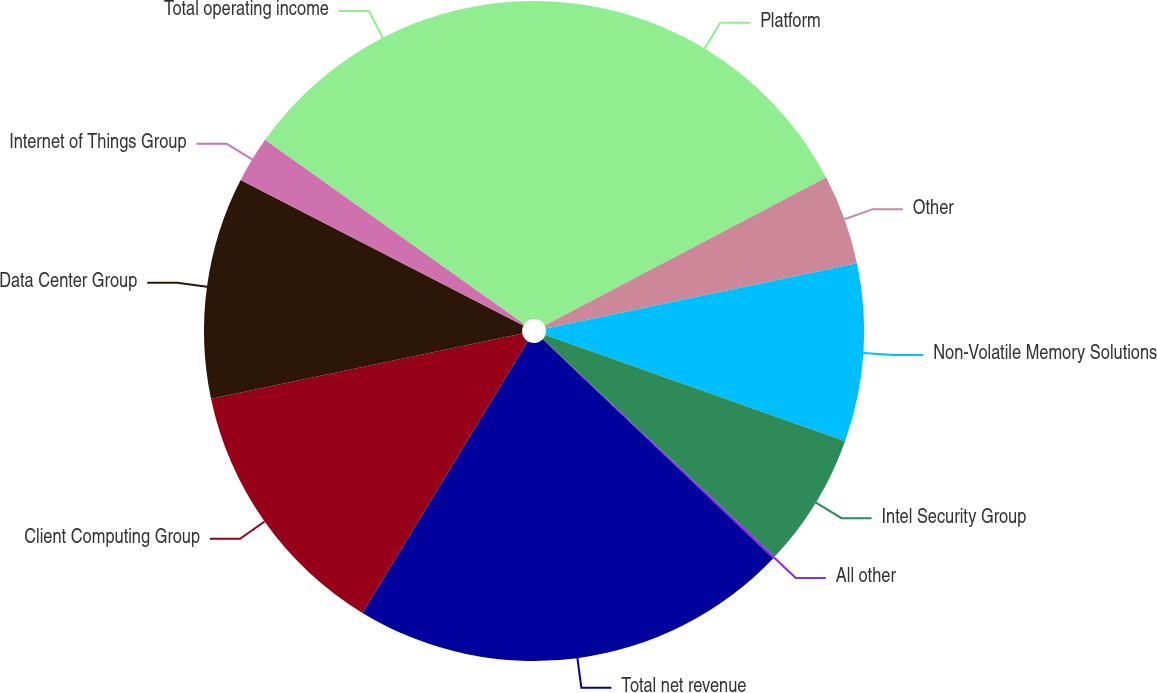<chart> <loc_0><loc_0><loc_500><loc_500><pie_chart><fcel>Platform<fcel>Other<fcel>Non-Volatile Memory Solutions<fcel>Intel Security Group<fcel>All other<fcel>Total net revenue<fcel>Client Computing Group<fcel>Data Center Group<fcel>Internet of Things Group<fcel>Total operating income<nl><fcel>17.3%<fcel>4.41%<fcel>8.71%<fcel>6.56%<fcel>0.12%<fcel>21.6%<fcel>13.01%<fcel>10.86%<fcel>2.27%<fcel>15.16%<nl></chart> 